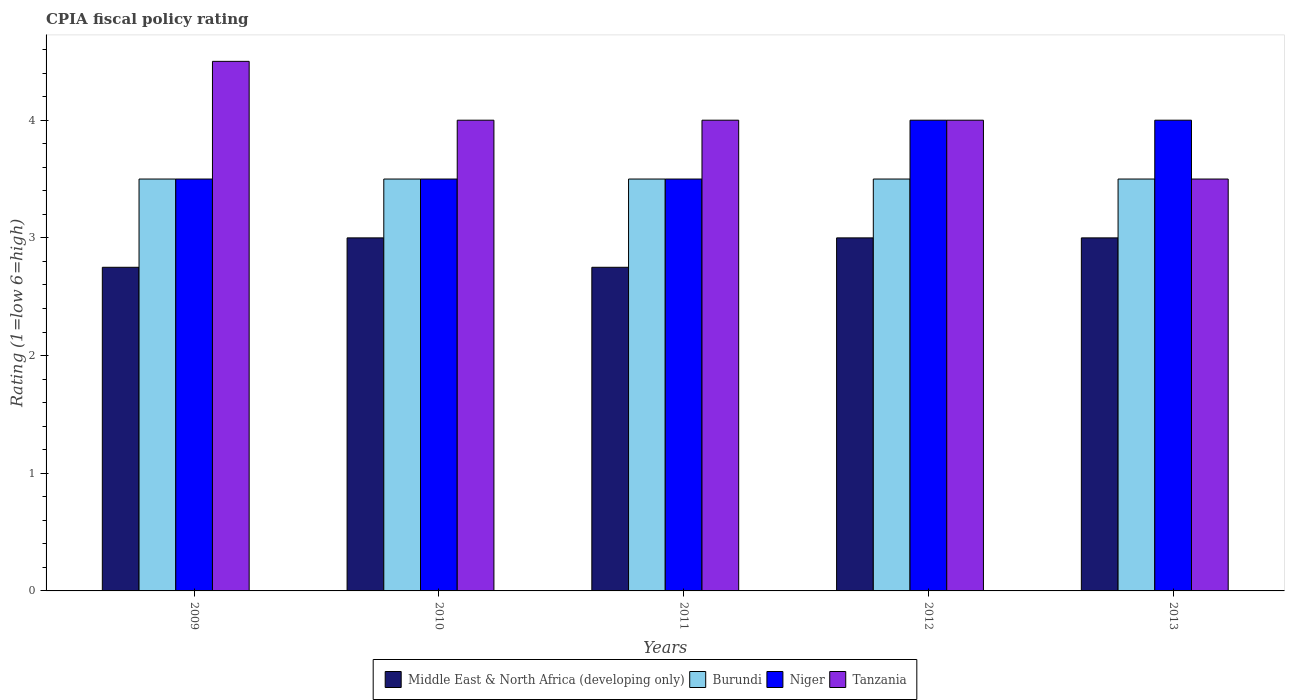How many different coloured bars are there?
Ensure brevity in your answer.  4. How many bars are there on the 5th tick from the left?
Offer a very short reply. 4. In how many cases, is the number of bars for a given year not equal to the number of legend labels?
Your answer should be very brief. 0. What is the CPIA rating in Middle East & North Africa (developing only) in 2011?
Your answer should be compact. 2.75. Across all years, what is the maximum CPIA rating in Burundi?
Provide a short and direct response. 3.5. What is the total CPIA rating in Niger in the graph?
Offer a terse response. 18.5. What is the difference between the CPIA rating in Middle East & North Africa (developing only) in 2010 and that in 2011?
Ensure brevity in your answer.  0.25. What is the average CPIA rating in Niger per year?
Offer a terse response. 3.7. In the year 2011, what is the difference between the CPIA rating in Tanzania and CPIA rating in Middle East & North Africa (developing only)?
Keep it short and to the point. 1.25. In how many years, is the CPIA rating in Middle East & North Africa (developing only) greater than 2.6?
Give a very brief answer. 5. What is the ratio of the CPIA rating in Burundi in 2009 to that in 2010?
Offer a terse response. 1. Is the CPIA rating in Tanzania in 2011 less than that in 2013?
Offer a terse response. No. Is the difference between the CPIA rating in Tanzania in 2009 and 2012 greater than the difference between the CPIA rating in Middle East & North Africa (developing only) in 2009 and 2012?
Offer a very short reply. Yes. What is the difference between the highest and the second highest CPIA rating in Tanzania?
Give a very brief answer. 0.5. What is the difference between the highest and the lowest CPIA rating in Middle East & North Africa (developing only)?
Offer a very short reply. 0.25. In how many years, is the CPIA rating in Middle East & North Africa (developing only) greater than the average CPIA rating in Middle East & North Africa (developing only) taken over all years?
Offer a very short reply. 3. What does the 2nd bar from the left in 2010 represents?
Ensure brevity in your answer.  Burundi. What does the 4th bar from the right in 2011 represents?
Keep it short and to the point. Middle East & North Africa (developing only). Is it the case that in every year, the sum of the CPIA rating in Burundi and CPIA rating in Tanzania is greater than the CPIA rating in Niger?
Provide a succinct answer. Yes. Are all the bars in the graph horizontal?
Give a very brief answer. No. How many years are there in the graph?
Keep it short and to the point. 5. Does the graph contain any zero values?
Your answer should be compact. No. How many legend labels are there?
Give a very brief answer. 4. How are the legend labels stacked?
Provide a succinct answer. Horizontal. What is the title of the graph?
Give a very brief answer. CPIA fiscal policy rating. What is the label or title of the X-axis?
Your answer should be very brief. Years. What is the label or title of the Y-axis?
Provide a succinct answer. Rating (1=low 6=high). What is the Rating (1=low 6=high) in Middle East & North Africa (developing only) in 2009?
Offer a terse response. 2.75. What is the Rating (1=low 6=high) of Niger in 2009?
Provide a short and direct response. 3.5. What is the Rating (1=low 6=high) in Tanzania in 2009?
Provide a short and direct response. 4.5. What is the Rating (1=low 6=high) of Middle East & North Africa (developing only) in 2010?
Your answer should be compact. 3. What is the Rating (1=low 6=high) in Burundi in 2010?
Your answer should be compact. 3.5. What is the Rating (1=low 6=high) in Niger in 2010?
Give a very brief answer. 3.5. What is the Rating (1=low 6=high) in Tanzania in 2010?
Give a very brief answer. 4. What is the Rating (1=low 6=high) of Middle East & North Africa (developing only) in 2011?
Provide a succinct answer. 2.75. What is the Rating (1=low 6=high) in Niger in 2011?
Ensure brevity in your answer.  3.5. What is the Rating (1=low 6=high) in Middle East & North Africa (developing only) in 2012?
Give a very brief answer. 3. What is the Rating (1=low 6=high) of Burundi in 2012?
Provide a succinct answer. 3.5. Across all years, what is the maximum Rating (1=low 6=high) in Niger?
Provide a short and direct response. 4. Across all years, what is the minimum Rating (1=low 6=high) of Middle East & North Africa (developing only)?
Ensure brevity in your answer.  2.75. Across all years, what is the minimum Rating (1=low 6=high) of Niger?
Ensure brevity in your answer.  3.5. Across all years, what is the minimum Rating (1=low 6=high) of Tanzania?
Ensure brevity in your answer.  3.5. What is the total Rating (1=low 6=high) of Burundi in the graph?
Ensure brevity in your answer.  17.5. What is the total Rating (1=low 6=high) of Tanzania in the graph?
Offer a terse response. 20. What is the difference between the Rating (1=low 6=high) in Burundi in 2009 and that in 2010?
Offer a terse response. 0. What is the difference between the Rating (1=low 6=high) in Niger in 2009 and that in 2010?
Your answer should be very brief. 0. What is the difference between the Rating (1=low 6=high) of Middle East & North Africa (developing only) in 2009 and that in 2012?
Offer a terse response. -0.25. What is the difference between the Rating (1=low 6=high) in Burundi in 2009 and that in 2013?
Offer a very short reply. 0. What is the difference between the Rating (1=low 6=high) of Tanzania in 2009 and that in 2013?
Keep it short and to the point. 1. What is the difference between the Rating (1=low 6=high) of Middle East & North Africa (developing only) in 2010 and that in 2011?
Provide a succinct answer. 0.25. What is the difference between the Rating (1=low 6=high) in Burundi in 2010 and that in 2011?
Offer a terse response. 0. What is the difference between the Rating (1=low 6=high) of Niger in 2010 and that in 2011?
Keep it short and to the point. 0. What is the difference between the Rating (1=low 6=high) in Tanzania in 2010 and that in 2011?
Offer a very short reply. 0. What is the difference between the Rating (1=low 6=high) of Middle East & North Africa (developing only) in 2010 and that in 2012?
Make the answer very short. 0. What is the difference between the Rating (1=low 6=high) in Burundi in 2010 and that in 2012?
Your response must be concise. 0. What is the difference between the Rating (1=low 6=high) in Middle East & North Africa (developing only) in 2010 and that in 2013?
Provide a short and direct response. 0. What is the difference between the Rating (1=low 6=high) in Niger in 2010 and that in 2013?
Your response must be concise. -0.5. What is the difference between the Rating (1=low 6=high) of Tanzania in 2010 and that in 2013?
Make the answer very short. 0.5. What is the difference between the Rating (1=low 6=high) of Burundi in 2011 and that in 2012?
Offer a very short reply. 0. What is the difference between the Rating (1=low 6=high) in Niger in 2011 and that in 2012?
Provide a short and direct response. -0.5. What is the difference between the Rating (1=low 6=high) of Middle East & North Africa (developing only) in 2012 and that in 2013?
Give a very brief answer. 0. What is the difference between the Rating (1=low 6=high) in Middle East & North Africa (developing only) in 2009 and the Rating (1=low 6=high) in Burundi in 2010?
Ensure brevity in your answer.  -0.75. What is the difference between the Rating (1=low 6=high) of Middle East & North Africa (developing only) in 2009 and the Rating (1=low 6=high) of Niger in 2010?
Your response must be concise. -0.75. What is the difference between the Rating (1=low 6=high) in Middle East & North Africa (developing only) in 2009 and the Rating (1=low 6=high) in Tanzania in 2010?
Your response must be concise. -1.25. What is the difference between the Rating (1=low 6=high) in Burundi in 2009 and the Rating (1=low 6=high) in Tanzania in 2010?
Ensure brevity in your answer.  -0.5. What is the difference between the Rating (1=low 6=high) of Middle East & North Africa (developing only) in 2009 and the Rating (1=low 6=high) of Burundi in 2011?
Offer a terse response. -0.75. What is the difference between the Rating (1=low 6=high) in Middle East & North Africa (developing only) in 2009 and the Rating (1=low 6=high) in Niger in 2011?
Make the answer very short. -0.75. What is the difference between the Rating (1=low 6=high) in Middle East & North Africa (developing only) in 2009 and the Rating (1=low 6=high) in Tanzania in 2011?
Provide a short and direct response. -1.25. What is the difference between the Rating (1=low 6=high) of Burundi in 2009 and the Rating (1=low 6=high) of Tanzania in 2011?
Offer a terse response. -0.5. What is the difference between the Rating (1=low 6=high) in Niger in 2009 and the Rating (1=low 6=high) in Tanzania in 2011?
Offer a terse response. -0.5. What is the difference between the Rating (1=low 6=high) of Middle East & North Africa (developing only) in 2009 and the Rating (1=low 6=high) of Burundi in 2012?
Provide a succinct answer. -0.75. What is the difference between the Rating (1=low 6=high) in Middle East & North Africa (developing only) in 2009 and the Rating (1=low 6=high) in Niger in 2012?
Offer a very short reply. -1.25. What is the difference between the Rating (1=low 6=high) in Middle East & North Africa (developing only) in 2009 and the Rating (1=low 6=high) in Tanzania in 2012?
Make the answer very short. -1.25. What is the difference between the Rating (1=low 6=high) of Burundi in 2009 and the Rating (1=low 6=high) of Niger in 2012?
Your answer should be compact. -0.5. What is the difference between the Rating (1=low 6=high) of Niger in 2009 and the Rating (1=low 6=high) of Tanzania in 2012?
Your response must be concise. -0.5. What is the difference between the Rating (1=low 6=high) in Middle East & North Africa (developing only) in 2009 and the Rating (1=low 6=high) in Burundi in 2013?
Make the answer very short. -0.75. What is the difference between the Rating (1=low 6=high) in Middle East & North Africa (developing only) in 2009 and the Rating (1=low 6=high) in Niger in 2013?
Provide a succinct answer. -1.25. What is the difference between the Rating (1=low 6=high) of Middle East & North Africa (developing only) in 2009 and the Rating (1=low 6=high) of Tanzania in 2013?
Keep it short and to the point. -0.75. What is the difference between the Rating (1=low 6=high) in Niger in 2009 and the Rating (1=low 6=high) in Tanzania in 2013?
Your answer should be very brief. 0. What is the difference between the Rating (1=low 6=high) of Middle East & North Africa (developing only) in 2010 and the Rating (1=low 6=high) of Niger in 2011?
Offer a very short reply. -0.5. What is the difference between the Rating (1=low 6=high) in Burundi in 2010 and the Rating (1=low 6=high) in Niger in 2011?
Provide a short and direct response. 0. What is the difference between the Rating (1=low 6=high) of Niger in 2010 and the Rating (1=low 6=high) of Tanzania in 2011?
Ensure brevity in your answer.  -0.5. What is the difference between the Rating (1=low 6=high) in Middle East & North Africa (developing only) in 2010 and the Rating (1=low 6=high) in Burundi in 2012?
Provide a succinct answer. -0.5. What is the difference between the Rating (1=low 6=high) in Middle East & North Africa (developing only) in 2010 and the Rating (1=low 6=high) in Niger in 2012?
Provide a short and direct response. -1. What is the difference between the Rating (1=low 6=high) of Burundi in 2010 and the Rating (1=low 6=high) of Niger in 2012?
Make the answer very short. -0.5. What is the difference between the Rating (1=low 6=high) of Burundi in 2010 and the Rating (1=low 6=high) of Tanzania in 2012?
Your answer should be compact. -0.5. What is the difference between the Rating (1=low 6=high) in Niger in 2010 and the Rating (1=low 6=high) in Tanzania in 2012?
Make the answer very short. -0.5. What is the difference between the Rating (1=low 6=high) of Middle East & North Africa (developing only) in 2010 and the Rating (1=low 6=high) of Burundi in 2013?
Provide a short and direct response. -0.5. What is the difference between the Rating (1=low 6=high) in Middle East & North Africa (developing only) in 2010 and the Rating (1=low 6=high) in Niger in 2013?
Provide a succinct answer. -1. What is the difference between the Rating (1=low 6=high) of Burundi in 2010 and the Rating (1=low 6=high) of Niger in 2013?
Your response must be concise. -0.5. What is the difference between the Rating (1=low 6=high) in Burundi in 2010 and the Rating (1=low 6=high) in Tanzania in 2013?
Your answer should be very brief. 0. What is the difference between the Rating (1=low 6=high) in Middle East & North Africa (developing only) in 2011 and the Rating (1=low 6=high) in Burundi in 2012?
Keep it short and to the point. -0.75. What is the difference between the Rating (1=low 6=high) in Middle East & North Africa (developing only) in 2011 and the Rating (1=low 6=high) in Niger in 2012?
Your answer should be compact. -1.25. What is the difference between the Rating (1=low 6=high) of Middle East & North Africa (developing only) in 2011 and the Rating (1=low 6=high) of Tanzania in 2012?
Your response must be concise. -1.25. What is the difference between the Rating (1=low 6=high) of Middle East & North Africa (developing only) in 2011 and the Rating (1=low 6=high) of Burundi in 2013?
Ensure brevity in your answer.  -0.75. What is the difference between the Rating (1=low 6=high) of Middle East & North Africa (developing only) in 2011 and the Rating (1=low 6=high) of Niger in 2013?
Offer a terse response. -1.25. What is the difference between the Rating (1=low 6=high) of Middle East & North Africa (developing only) in 2011 and the Rating (1=low 6=high) of Tanzania in 2013?
Offer a very short reply. -0.75. What is the difference between the Rating (1=low 6=high) of Burundi in 2011 and the Rating (1=low 6=high) of Niger in 2013?
Provide a short and direct response. -0.5. What is the difference between the Rating (1=low 6=high) in Burundi in 2011 and the Rating (1=low 6=high) in Tanzania in 2013?
Your answer should be very brief. 0. What is the difference between the Rating (1=low 6=high) of Middle East & North Africa (developing only) in 2012 and the Rating (1=low 6=high) of Niger in 2013?
Your answer should be very brief. -1. What is the difference between the Rating (1=low 6=high) in Middle East & North Africa (developing only) in 2012 and the Rating (1=low 6=high) in Tanzania in 2013?
Keep it short and to the point. -0.5. What is the difference between the Rating (1=low 6=high) of Burundi in 2012 and the Rating (1=low 6=high) of Niger in 2013?
Give a very brief answer. -0.5. What is the difference between the Rating (1=low 6=high) of Burundi in 2012 and the Rating (1=low 6=high) of Tanzania in 2013?
Your answer should be very brief. 0. What is the average Rating (1=low 6=high) of Niger per year?
Offer a very short reply. 3.7. What is the average Rating (1=low 6=high) of Tanzania per year?
Make the answer very short. 4. In the year 2009, what is the difference between the Rating (1=low 6=high) of Middle East & North Africa (developing only) and Rating (1=low 6=high) of Burundi?
Keep it short and to the point. -0.75. In the year 2009, what is the difference between the Rating (1=low 6=high) in Middle East & North Africa (developing only) and Rating (1=low 6=high) in Niger?
Provide a succinct answer. -0.75. In the year 2009, what is the difference between the Rating (1=low 6=high) of Middle East & North Africa (developing only) and Rating (1=low 6=high) of Tanzania?
Make the answer very short. -1.75. In the year 2009, what is the difference between the Rating (1=low 6=high) of Burundi and Rating (1=low 6=high) of Niger?
Provide a short and direct response. 0. In the year 2009, what is the difference between the Rating (1=low 6=high) of Niger and Rating (1=low 6=high) of Tanzania?
Offer a terse response. -1. In the year 2010, what is the difference between the Rating (1=low 6=high) of Middle East & North Africa (developing only) and Rating (1=low 6=high) of Niger?
Offer a very short reply. -0.5. In the year 2010, what is the difference between the Rating (1=low 6=high) in Burundi and Rating (1=low 6=high) in Niger?
Offer a terse response. 0. In the year 2010, what is the difference between the Rating (1=low 6=high) of Burundi and Rating (1=low 6=high) of Tanzania?
Ensure brevity in your answer.  -0.5. In the year 2011, what is the difference between the Rating (1=low 6=high) of Middle East & North Africa (developing only) and Rating (1=low 6=high) of Burundi?
Your answer should be very brief. -0.75. In the year 2011, what is the difference between the Rating (1=low 6=high) in Middle East & North Africa (developing only) and Rating (1=low 6=high) in Niger?
Your answer should be very brief. -0.75. In the year 2011, what is the difference between the Rating (1=low 6=high) of Middle East & North Africa (developing only) and Rating (1=low 6=high) of Tanzania?
Your answer should be compact. -1.25. In the year 2011, what is the difference between the Rating (1=low 6=high) of Burundi and Rating (1=low 6=high) of Niger?
Keep it short and to the point. 0. In the year 2011, what is the difference between the Rating (1=low 6=high) in Niger and Rating (1=low 6=high) in Tanzania?
Offer a terse response. -0.5. In the year 2012, what is the difference between the Rating (1=low 6=high) in Middle East & North Africa (developing only) and Rating (1=low 6=high) in Burundi?
Give a very brief answer. -0.5. In the year 2012, what is the difference between the Rating (1=low 6=high) in Middle East & North Africa (developing only) and Rating (1=low 6=high) in Niger?
Offer a very short reply. -1. In the year 2012, what is the difference between the Rating (1=low 6=high) of Burundi and Rating (1=low 6=high) of Tanzania?
Your response must be concise. -0.5. In the year 2012, what is the difference between the Rating (1=low 6=high) in Niger and Rating (1=low 6=high) in Tanzania?
Offer a very short reply. 0. In the year 2013, what is the difference between the Rating (1=low 6=high) in Middle East & North Africa (developing only) and Rating (1=low 6=high) in Burundi?
Provide a short and direct response. -0.5. In the year 2013, what is the difference between the Rating (1=low 6=high) of Middle East & North Africa (developing only) and Rating (1=low 6=high) of Niger?
Offer a very short reply. -1. In the year 2013, what is the difference between the Rating (1=low 6=high) in Burundi and Rating (1=low 6=high) in Niger?
Your answer should be very brief. -0.5. In the year 2013, what is the difference between the Rating (1=low 6=high) in Burundi and Rating (1=low 6=high) in Tanzania?
Ensure brevity in your answer.  0. What is the ratio of the Rating (1=low 6=high) in Niger in 2009 to that in 2010?
Provide a succinct answer. 1. What is the ratio of the Rating (1=low 6=high) of Burundi in 2009 to that in 2011?
Offer a terse response. 1. What is the ratio of the Rating (1=low 6=high) in Niger in 2009 to that in 2011?
Your response must be concise. 1. What is the ratio of the Rating (1=low 6=high) in Middle East & North Africa (developing only) in 2009 to that in 2012?
Offer a terse response. 0.92. What is the ratio of the Rating (1=low 6=high) in Burundi in 2009 to that in 2012?
Provide a succinct answer. 1. What is the ratio of the Rating (1=low 6=high) in Tanzania in 2009 to that in 2012?
Make the answer very short. 1.12. What is the ratio of the Rating (1=low 6=high) of Middle East & North Africa (developing only) in 2009 to that in 2013?
Your response must be concise. 0.92. What is the ratio of the Rating (1=low 6=high) in Burundi in 2009 to that in 2013?
Keep it short and to the point. 1. What is the ratio of the Rating (1=low 6=high) in Niger in 2009 to that in 2013?
Your answer should be compact. 0.88. What is the ratio of the Rating (1=low 6=high) in Tanzania in 2009 to that in 2013?
Make the answer very short. 1.29. What is the ratio of the Rating (1=low 6=high) of Middle East & North Africa (developing only) in 2010 to that in 2011?
Keep it short and to the point. 1.09. What is the ratio of the Rating (1=low 6=high) in Burundi in 2010 to that in 2011?
Keep it short and to the point. 1. What is the ratio of the Rating (1=low 6=high) of Tanzania in 2010 to that in 2011?
Your answer should be very brief. 1. What is the ratio of the Rating (1=low 6=high) of Middle East & North Africa (developing only) in 2010 to that in 2012?
Offer a terse response. 1. What is the ratio of the Rating (1=low 6=high) of Tanzania in 2010 to that in 2012?
Your answer should be very brief. 1. What is the ratio of the Rating (1=low 6=high) of Niger in 2010 to that in 2013?
Offer a very short reply. 0.88. What is the ratio of the Rating (1=low 6=high) of Tanzania in 2010 to that in 2013?
Your answer should be compact. 1.14. What is the ratio of the Rating (1=low 6=high) in Burundi in 2011 to that in 2012?
Your answer should be very brief. 1. What is the ratio of the Rating (1=low 6=high) of Niger in 2011 to that in 2012?
Your answer should be very brief. 0.88. What is the ratio of the Rating (1=low 6=high) of Tanzania in 2011 to that in 2012?
Provide a succinct answer. 1. What is the ratio of the Rating (1=low 6=high) in Niger in 2011 to that in 2013?
Your response must be concise. 0.88. What is the ratio of the Rating (1=low 6=high) in Middle East & North Africa (developing only) in 2012 to that in 2013?
Offer a very short reply. 1. What is the ratio of the Rating (1=low 6=high) of Niger in 2012 to that in 2013?
Offer a very short reply. 1. What is the ratio of the Rating (1=low 6=high) in Tanzania in 2012 to that in 2013?
Keep it short and to the point. 1.14. What is the difference between the highest and the second highest Rating (1=low 6=high) of Middle East & North Africa (developing only)?
Provide a short and direct response. 0. What is the difference between the highest and the second highest Rating (1=low 6=high) of Burundi?
Provide a succinct answer. 0. What is the difference between the highest and the second highest Rating (1=low 6=high) of Niger?
Your answer should be very brief. 0. What is the difference between the highest and the second highest Rating (1=low 6=high) in Tanzania?
Your answer should be compact. 0.5. 